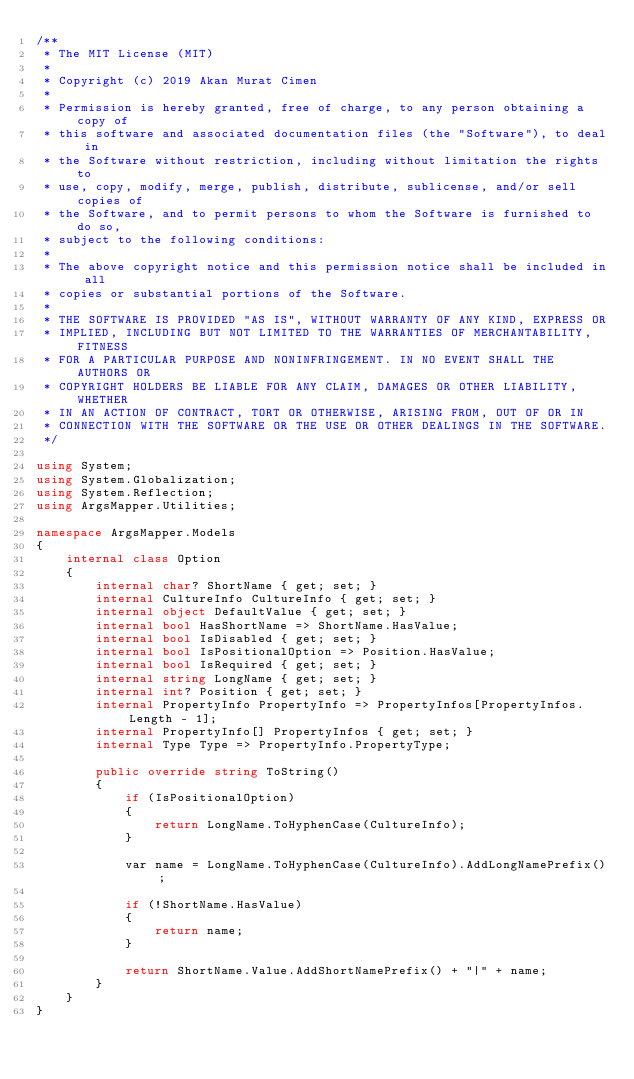<code> <loc_0><loc_0><loc_500><loc_500><_C#_>/**
 * The MIT License (MIT)
 * 
 * Copyright (c) 2019 Akan Murat Cimen
 * 
 * Permission is hereby granted, free of charge, to any person obtaining a copy of
 * this software and associated documentation files (the "Software"), to deal in
 * the Software without restriction, including without limitation the rights to
 * use, copy, modify, merge, publish, distribute, sublicense, and/or sell copies of
 * the Software, and to permit persons to whom the Software is furnished to do so,
 * subject to the following conditions:
 * 
 * The above copyright notice and this permission notice shall be included in all
 * copies or substantial portions of the Software.
 * 
 * THE SOFTWARE IS PROVIDED "AS IS", WITHOUT WARRANTY OF ANY KIND, EXPRESS OR
 * IMPLIED, INCLUDING BUT NOT LIMITED TO THE WARRANTIES OF MERCHANTABILITY, FITNESS
 * FOR A PARTICULAR PURPOSE AND NONINFRINGEMENT. IN NO EVENT SHALL THE AUTHORS OR
 * COPYRIGHT HOLDERS BE LIABLE FOR ANY CLAIM, DAMAGES OR OTHER LIABILITY, WHETHER
 * IN AN ACTION OF CONTRACT, TORT OR OTHERWISE, ARISING FROM, OUT OF OR IN
 * CONNECTION WITH THE SOFTWARE OR THE USE OR OTHER DEALINGS IN THE SOFTWARE.
 */

using System;
using System.Globalization;
using System.Reflection;
using ArgsMapper.Utilities;

namespace ArgsMapper.Models
{
    internal class Option
    {
        internal char? ShortName { get; set; }
        internal CultureInfo CultureInfo { get; set; }
        internal object DefaultValue { get; set; }
        internal bool HasShortName => ShortName.HasValue;
        internal bool IsDisabled { get; set; }
        internal bool IsPositionalOption => Position.HasValue;
        internal bool IsRequired { get; set; }
        internal string LongName { get; set; }
        internal int? Position { get; set; }
        internal PropertyInfo PropertyInfo => PropertyInfos[PropertyInfos.Length - 1];
        internal PropertyInfo[] PropertyInfos { get; set; }
        internal Type Type => PropertyInfo.PropertyType;

        public override string ToString()
        {
            if (IsPositionalOption)
            {
                return LongName.ToHyphenCase(CultureInfo);
            }

            var name = LongName.ToHyphenCase(CultureInfo).AddLongNamePrefix();

            if (!ShortName.HasValue)
            {
                return name;
            }

            return ShortName.Value.AddShortNamePrefix() + "|" + name;
        }
    }
}
</code> 